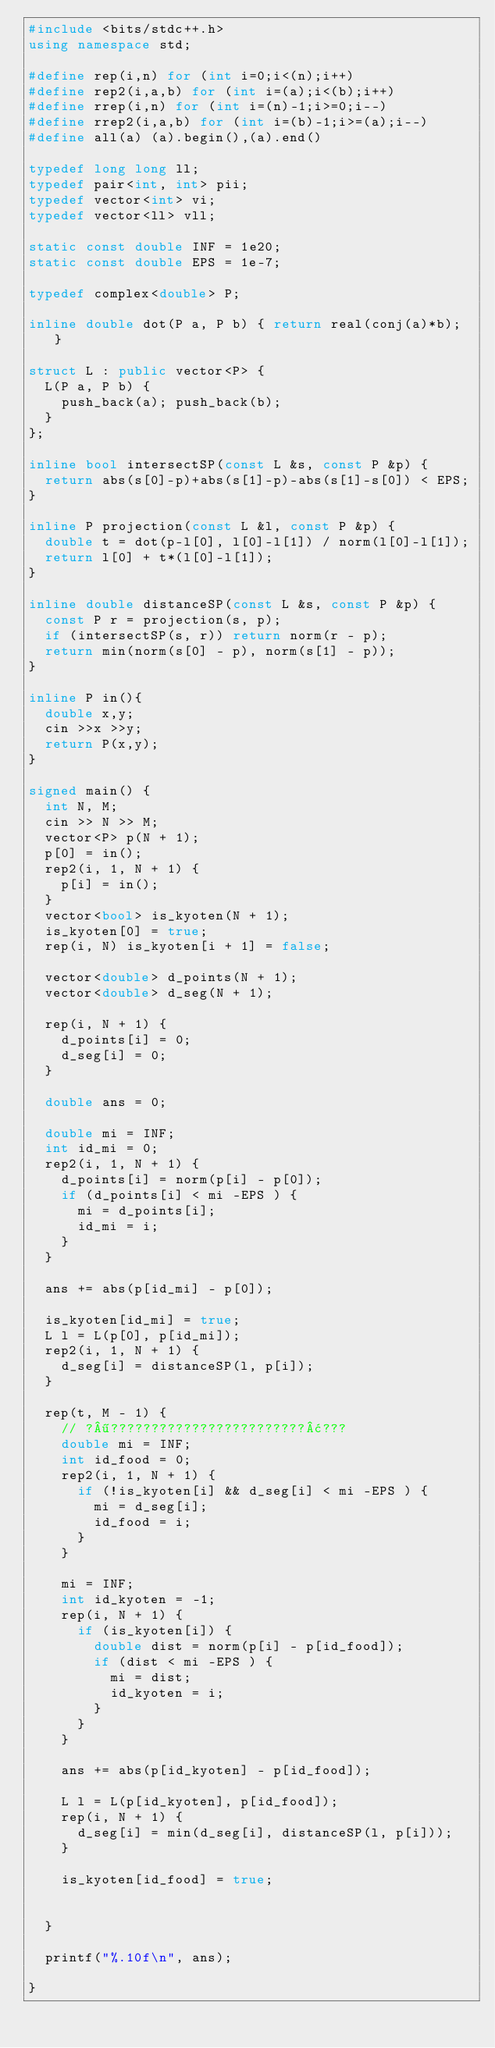Convert code to text. <code><loc_0><loc_0><loc_500><loc_500><_C++_>#include <bits/stdc++.h>
using namespace std;

#define rep(i,n) for (int i=0;i<(n);i++)
#define rep2(i,a,b) for (int i=(a);i<(b);i++)
#define rrep(i,n) for (int i=(n)-1;i>=0;i--)
#define rrep2(i,a,b) for (int i=(b)-1;i>=(a);i--)
#define all(a) (a).begin(),(a).end()

typedef long long ll;
typedef pair<int, int> pii;
typedef vector<int> vi;
typedef vector<ll> vll;

static const double INF = 1e20;
static const double EPS = 1e-7;

typedef complex<double> P;

inline double dot(P a, P b) { return real(conj(a)*b); }

struct L : public vector<P> {
	L(P a, P b) {
		push_back(a); push_back(b);
	}
};

inline bool intersectSP(const L &s, const P &p) {
	return abs(s[0]-p)+abs(s[1]-p)-abs(s[1]-s[0]) < EPS;
}

inline P projection(const L &l, const P &p) {
	double t = dot(p-l[0], l[0]-l[1]) / norm(l[0]-l[1]);
	return l[0] + t*(l[0]-l[1]);
}

inline double distanceSP(const L &s, const P &p) {
	const P r = projection(s, p);
	if (intersectSP(s, r)) return norm(r - p);
	return min(norm(s[0] - p), norm(s[1] - p));
}

inline P in(){
	double x,y;
	cin >>x >>y;
	return P(x,y);
}

signed main() {
	int N, M;
	cin >> N >> M;
	vector<P> p(N + 1);
	p[0] = in();
	rep2(i, 1, N + 1) {
		p[i] = in();
	}
	vector<bool> is_kyoten(N + 1);
	is_kyoten[0] = true;
	rep(i, N) is_kyoten[i + 1] = false;

	vector<double> d_points(N + 1);
	vector<double> d_seg(N + 1);

	rep(i, N + 1) {
		d_points[i] = 0;
		d_seg[i] = 0;
	}

	double ans = 0;

	double mi = INF;
	int id_mi = 0;
	rep2(i, 1, N + 1) {
		d_points[i] = norm(p[i] - p[0]);
		if (d_points[i] < mi -EPS ) {
			mi = d_points[i];
			id_mi = i;
		}
	}

	ans += abs(p[id_mi] - p[0]);

	is_kyoten[id_mi] = true;
	L l = L(p[0], p[id_mi]);
	rep2(i, 1, N + 1) {
		d_seg[i] = distanceSP(l, p[i]);
	}

	rep(t, M - 1) {
		// ?¶????????????????????????¢???
		double mi = INF;
		int id_food = 0;
		rep2(i, 1, N + 1) {
			if (!is_kyoten[i] && d_seg[i] < mi -EPS ) {
				mi = d_seg[i];
				id_food = i;
			}
		}

		mi = INF;
		int id_kyoten = -1;
		rep(i, N + 1) {
			if (is_kyoten[i]) {
				double dist = norm(p[i] - p[id_food]);
				if (dist < mi -EPS ) {
					mi = dist;
					id_kyoten = i;
				}
			}
		}

		ans += abs(p[id_kyoten] - p[id_food]);

		L l = L(p[id_kyoten], p[id_food]);
		rep(i, N + 1) {
			d_seg[i] = min(d_seg[i], distanceSP(l, p[i]));
		}

		is_kyoten[id_food] = true;


	}

	printf("%.10f\n", ans);

}</code> 